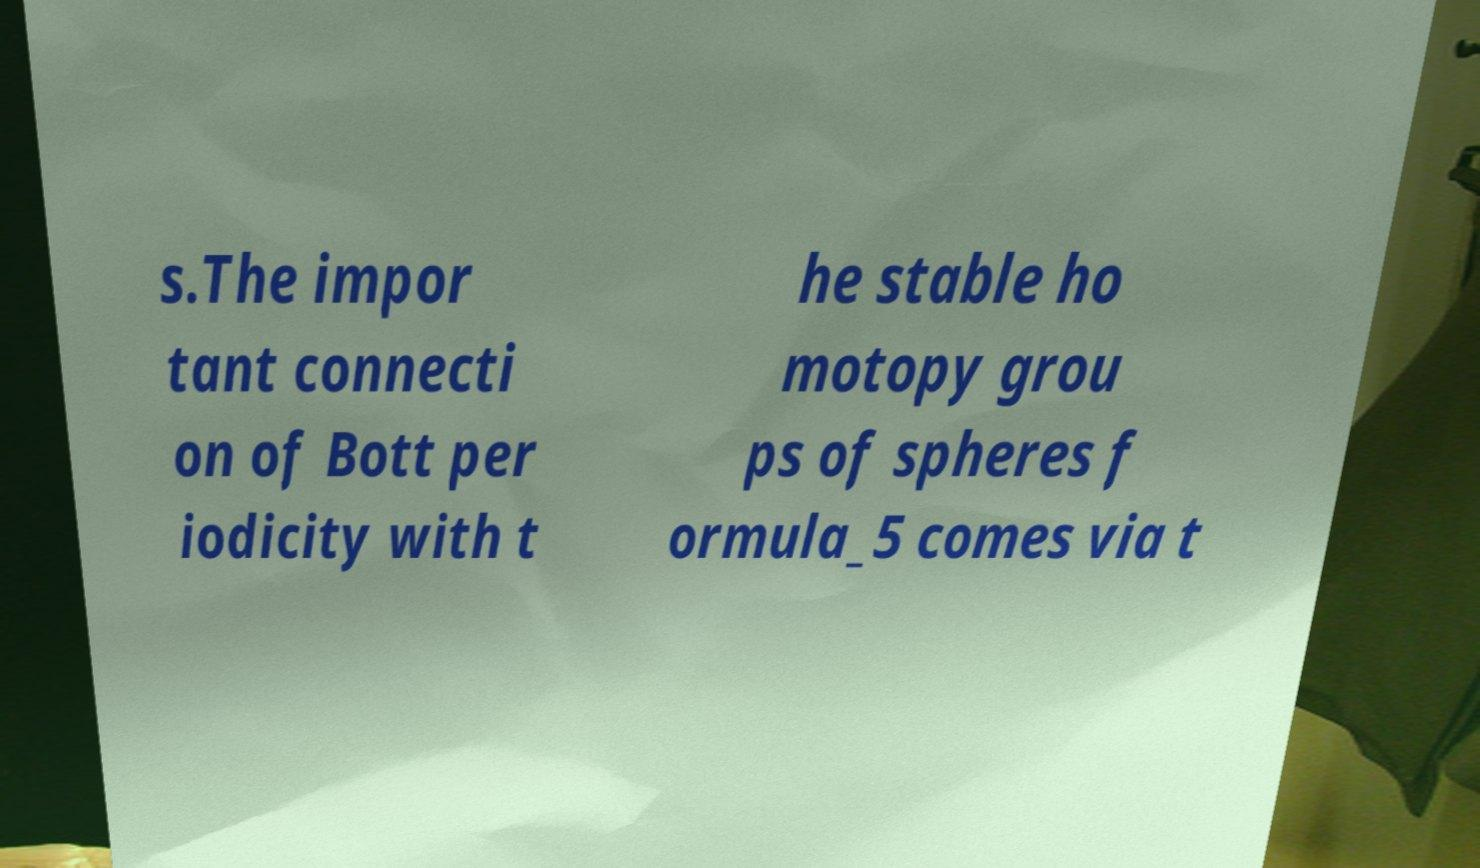Can you accurately transcribe the text from the provided image for me? s.The impor tant connecti on of Bott per iodicity with t he stable ho motopy grou ps of spheres f ormula_5 comes via t 